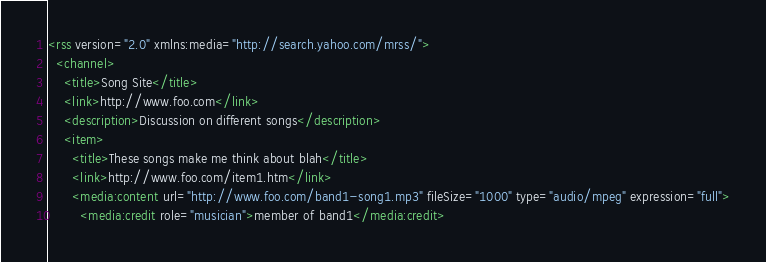Convert code to text. <code><loc_0><loc_0><loc_500><loc_500><_XML_><rss version="2.0" xmlns:media="http://search.yahoo.com/mrss/">
  <channel>
    <title>Song Site</title>
    <link>http://www.foo.com</link>
    <description>Discussion on different songs</description>
    <item>
      <title>These songs make me think about blah</title>
      <link>http://www.foo.com/item1.htm</link>
      <media:content url="http://www.foo.com/band1-song1.mp3" fileSize="1000" type="audio/mpeg" expression="full">
        <media:credit role="musician">member of band1</media:credit></code> 